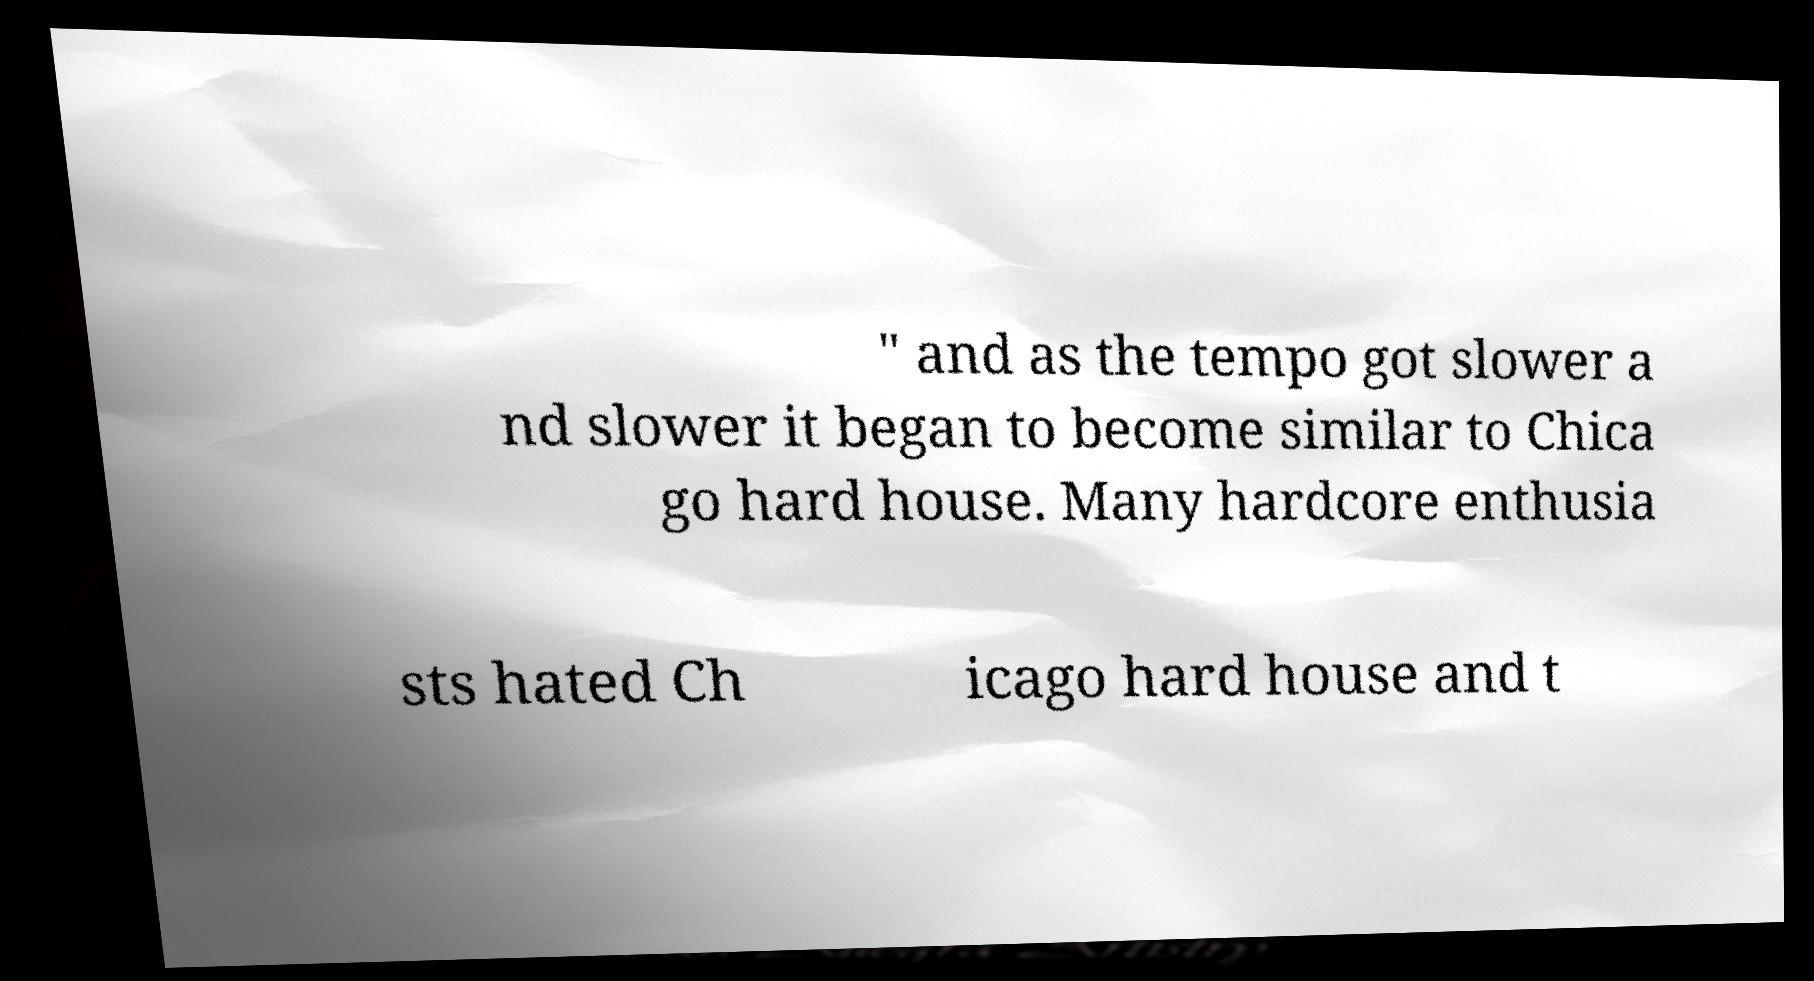I need the written content from this picture converted into text. Can you do that? " and as the tempo got slower a nd slower it began to become similar to Chica go hard house. Many hardcore enthusia sts hated Ch icago hard house and t 